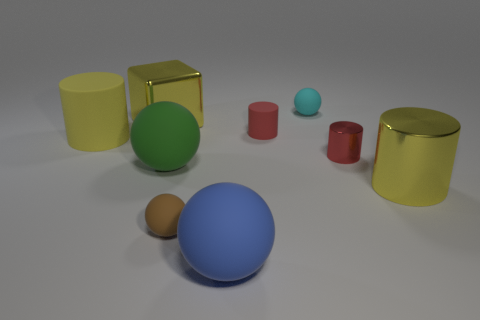Subtract all balls. How many objects are left? 5 Subtract 0 blue cylinders. How many objects are left? 9 Subtract all gray cubes. Subtract all tiny shiny things. How many objects are left? 8 Add 1 large yellow rubber objects. How many large yellow rubber objects are left? 2 Add 3 yellow metal cylinders. How many yellow metal cylinders exist? 4 